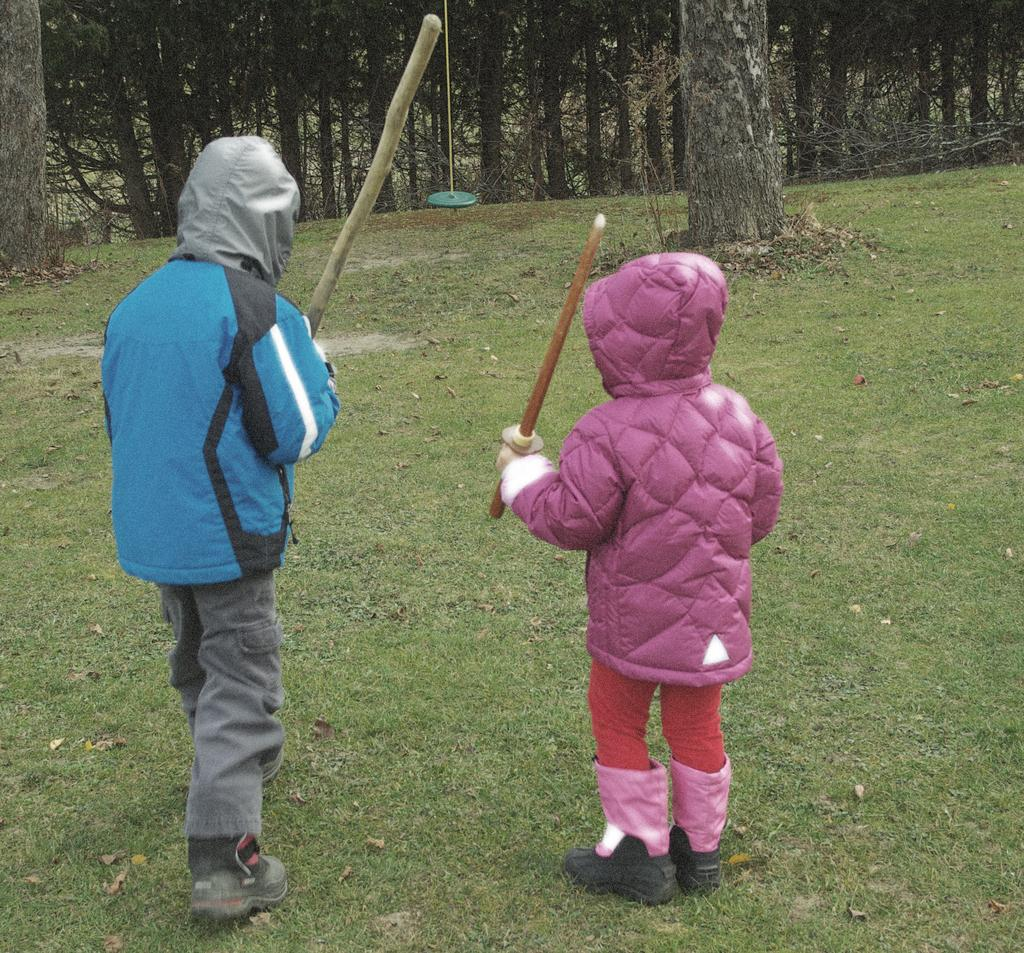How many people are in the image? There are two persons in the image. What are the persons holding in their hands? The persons are holding sticks. What type of terrain is visible at the bottom of the image? There is grass at the bottom of the image. What can be seen in the background of the image? There are trees, grass, and other objects in the background of the image. What type of bed can be seen in the image? There is no bed present in the image. What kind of loaf is being prepared by the persons in the image? There is no loaf or baking activity depicted in the image. 